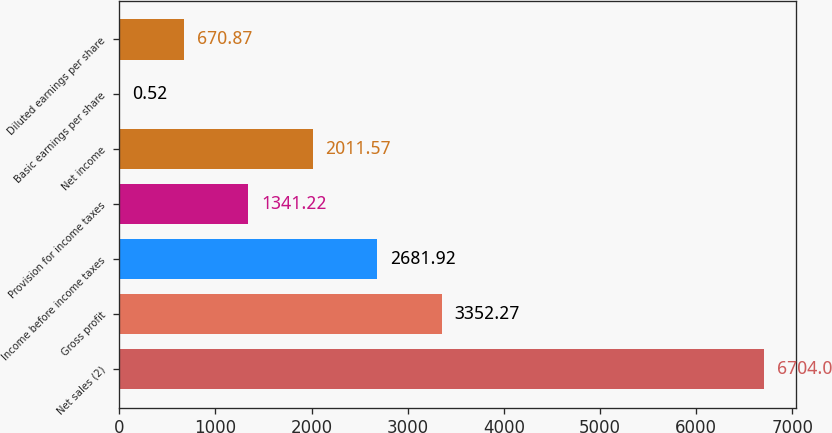<chart> <loc_0><loc_0><loc_500><loc_500><bar_chart><fcel>Net sales (2)<fcel>Gross profit<fcel>Income before income taxes<fcel>Provision for income taxes<fcel>Net income<fcel>Basic earnings per share<fcel>Diluted earnings per share<nl><fcel>6704<fcel>3352.27<fcel>2681.92<fcel>1341.22<fcel>2011.57<fcel>0.52<fcel>670.87<nl></chart> 